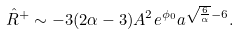<formula> <loc_0><loc_0><loc_500><loc_500>\hat { R } ^ { + } \sim - 3 ( 2 \alpha - 3 ) A ^ { 2 } e ^ { \phi _ { 0 } } a ^ { \sqrt { \frac { 6 } { \alpha } } - 6 } .</formula> 